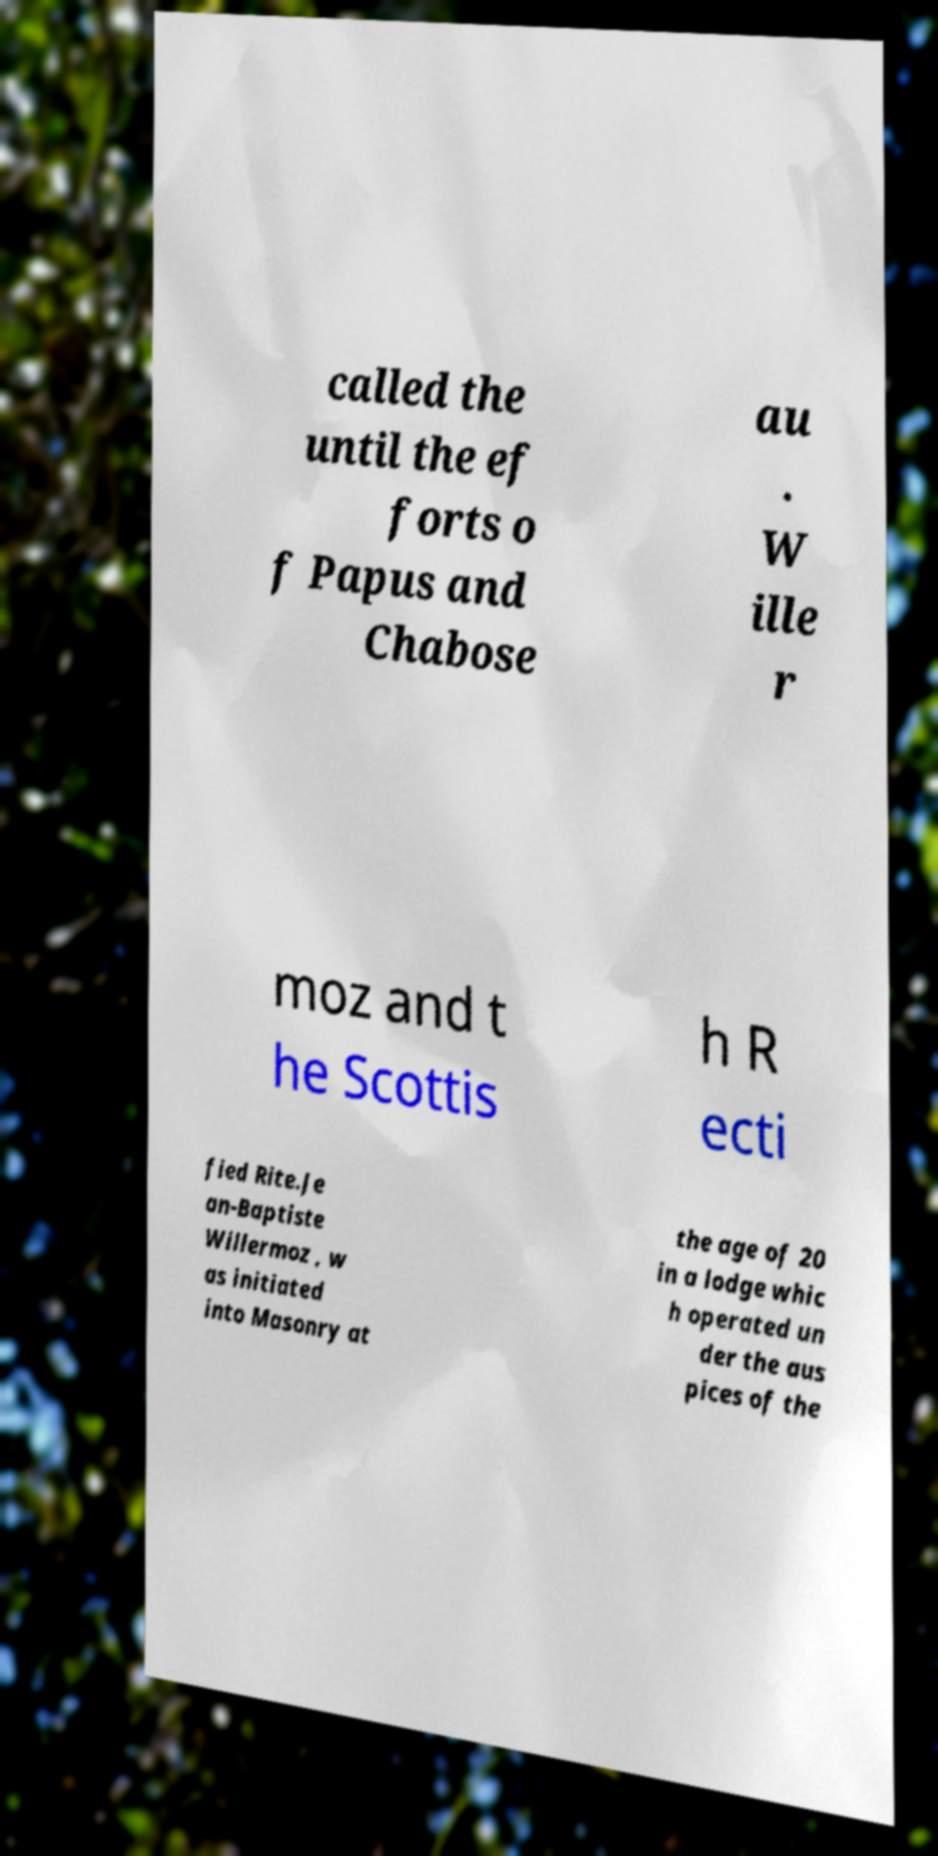Please identify and transcribe the text found in this image. called the until the ef forts o f Papus and Chabose au . W ille r moz and t he Scottis h R ecti fied Rite.Je an-Baptiste Willermoz , w as initiated into Masonry at the age of 20 in a lodge whic h operated un der the aus pices of the 